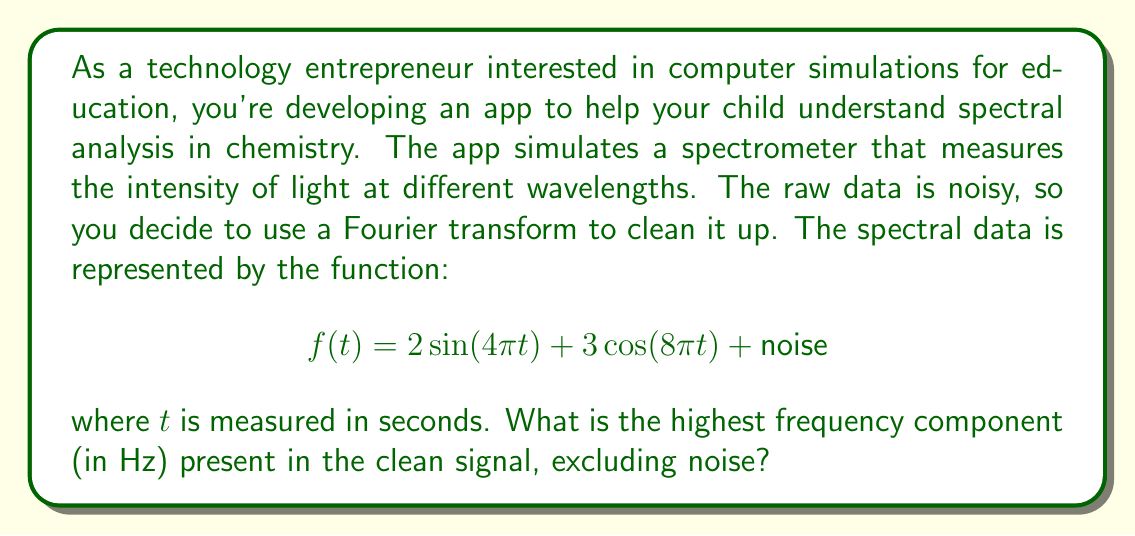Provide a solution to this math problem. To solve this problem, we need to analyze the given function and identify the highest frequency component. Let's break it down step-by-step:

1) The given function is:
   $$f(t) = 2\sin(4\pi t) + 3\cos(8\pi t) + \text{noise}$$

2) We can ignore the noise term as we're asked about the clean signal.

3) Let's look at each term:
   a) $2\sin(4\pi t)$
   b) $3\cos(8\pi t)$

4) For a sinusoidal function of the form $\sin(2\pi ft)$ or $\cos(2\pi ft)$, $f$ represents the frequency in Hz.

5) For the first term:
   $2\sin(4\pi t) = 2\sin(2\pi(2)t)$
   So, $f_1 = 2$ Hz

6) For the second term:
   $3\cos(8\pi t) = 3\cos(2\pi(4)t)$
   So, $f_2 = 4$ Hz

7) The highest frequency is the larger of these two: $\max(f_1, f_2) = \max(2, 4) = 4$ Hz

Therefore, the highest frequency component in the clean signal is 4 Hz.
Answer: 4 Hz 